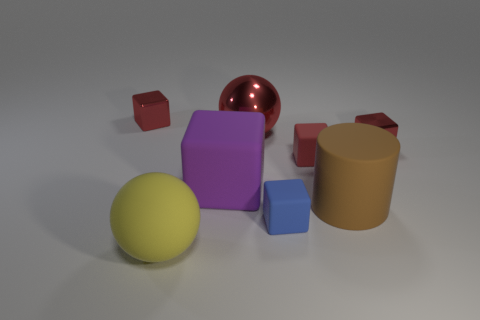Subtract all purple cylinders. How many red blocks are left? 3 Subtract all purple matte blocks. How many blocks are left? 4 Subtract all purple cubes. How many cubes are left? 4 Subtract 2 blocks. How many blocks are left? 3 Subtract all cyan blocks. Subtract all blue cylinders. How many blocks are left? 5 Add 2 large yellow matte balls. How many objects exist? 10 Subtract all balls. How many objects are left? 6 Add 7 green metallic cubes. How many green metallic cubes exist? 7 Subtract 0 gray cylinders. How many objects are left? 8 Subtract all large purple matte objects. Subtract all metallic balls. How many objects are left? 6 